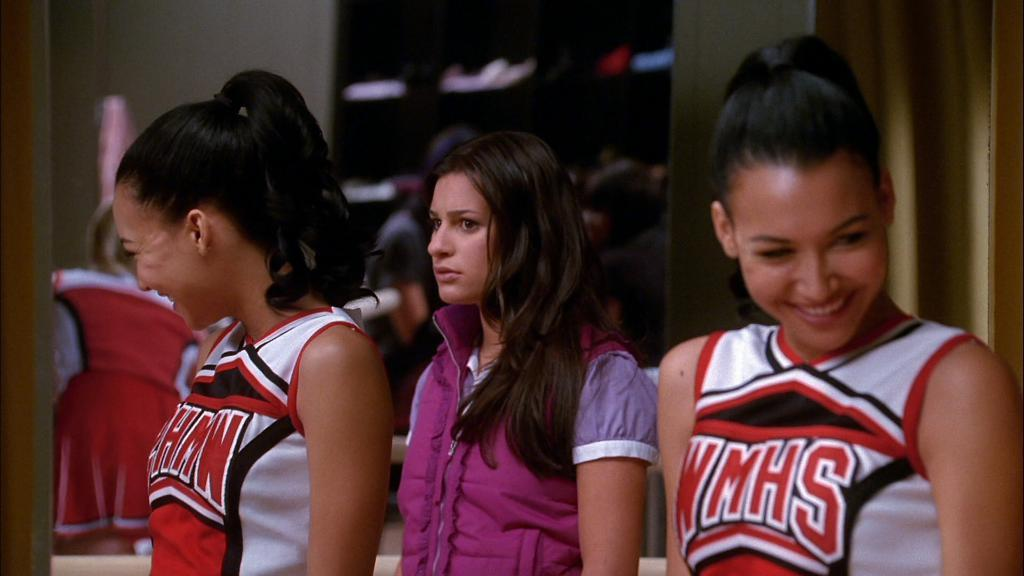<image>
Provide a brief description of the given image. The WMHS cheerleader is smiling, but the other girl is not. 